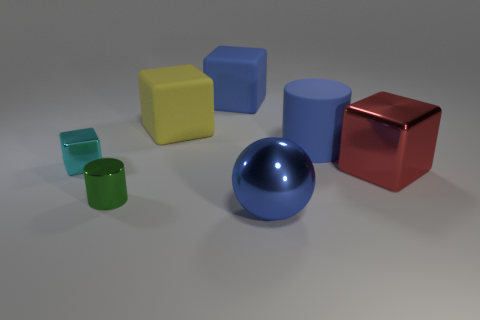Is the number of yellow objects on the right side of the blue cylinder less than the number of large rubber objects behind the blue rubber cube?
Offer a very short reply. No. Is there a metal thing that has the same color as the small cylinder?
Ensure brevity in your answer.  No. Does the cyan block have the same material as the cylinder that is behind the small cyan metal block?
Your answer should be very brief. No. Is there a block that is behind the shiny block that is on the left side of the blue matte cube?
Ensure brevity in your answer.  Yes. What is the color of the large thing that is in front of the large yellow rubber cube and behind the small metallic cube?
Your response must be concise. Blue. What size is the cyan metal block?
Offer a very short reply. Small. How many green metal objects are the same size as the yellow block?
Provide a short and direct response. 0. Is the cylinder that is right of the tiny green thing made of the same material as the cylinder on the left side of the blue ball?
Make the answer very short. No. What material is the big thing that is on the left side of the large blue matte object to the left of the blue ball?
Provide a succinct answer. Rubber. There is a cylinder behind the tiny metallic cube; what material is it?
Make the answer very short. Rubber. 